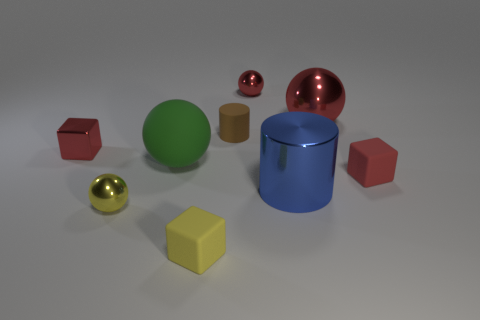Subtract all cylinders. How many objects are left? 7 Subtract all balls. Subtract all green balls. How many objects are left? 4 Add 4 brown rubber objects. How many brown rubber objects are left? 5 Add 2 cyan metal cylinders. How many cyan metal cylinders exist? 2 Subtract 0 purple cubes. How many objects are left? 9 